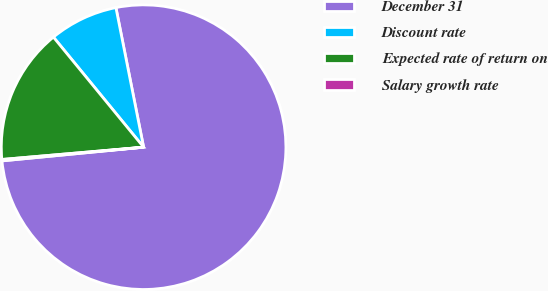Convert chart to OTSL. <chart><loc_0><loc_0><loc_500><loc_500><pie_chart><fcel>December 31<fcel>Discount rate<fcel>Expected rate of return on<fcel>Salary growth rate<nl><fcel>76.58%<fcel>7.81%<fcel>15.45%<fcel>0.16%<nl></chart> 